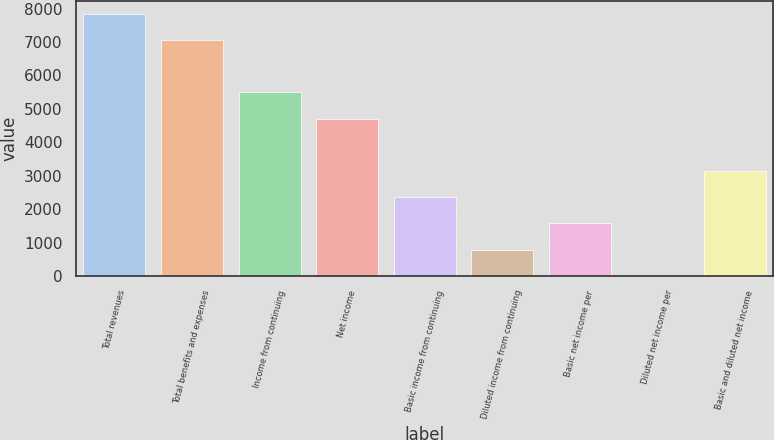<chart> <loc_0><loc_0><loc_500><loc_500><bar_chart><fcel>Total revenues<fcel>Total benefits and expenses<fcel>Income from continuing<fcel>Net income<fcel>Basic income from continuing<fcel>Diluted income from continuing<fcel>Basic net income per<fcel>Diluted net income per<fcel>Basic and diluted net income<nl><fcel>7850<fcel>7065.12<fcel>5495.4<fcel>4710.54<fcel>2355.96<fcel>786.24<fcel>1571.1<fcel>1.38<fcel>3140.82<nl></chart> 